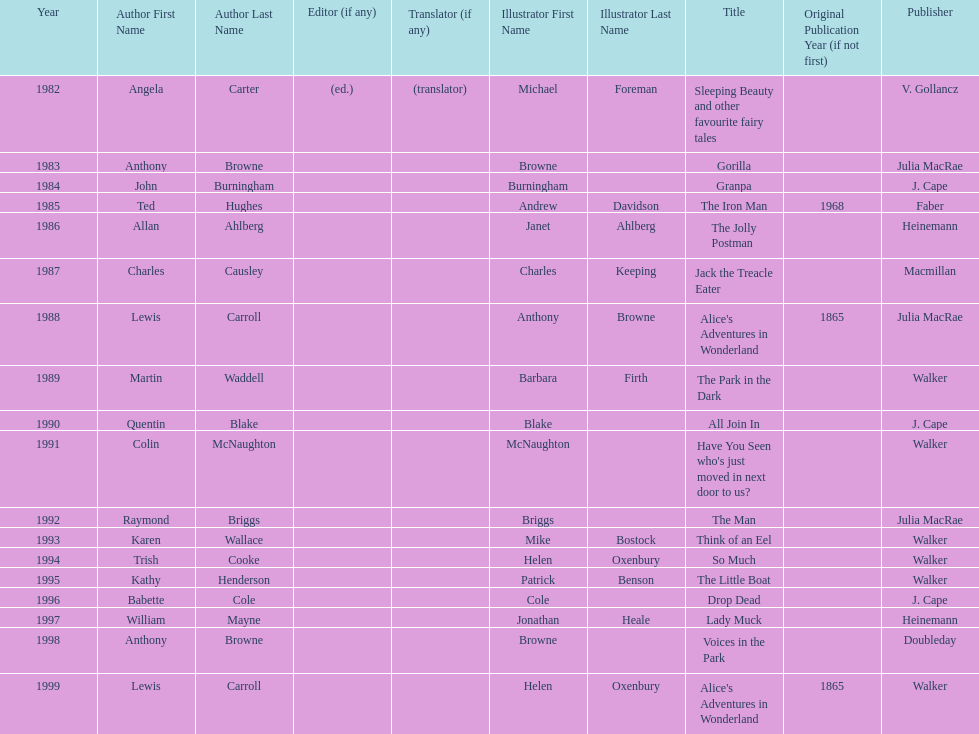How many total titles were published by walker? 5. 